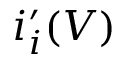<formula> <loc_0><loc_0><loc_500><loc_500>i _ { i } ^ { \prime } ( V )</formula> 